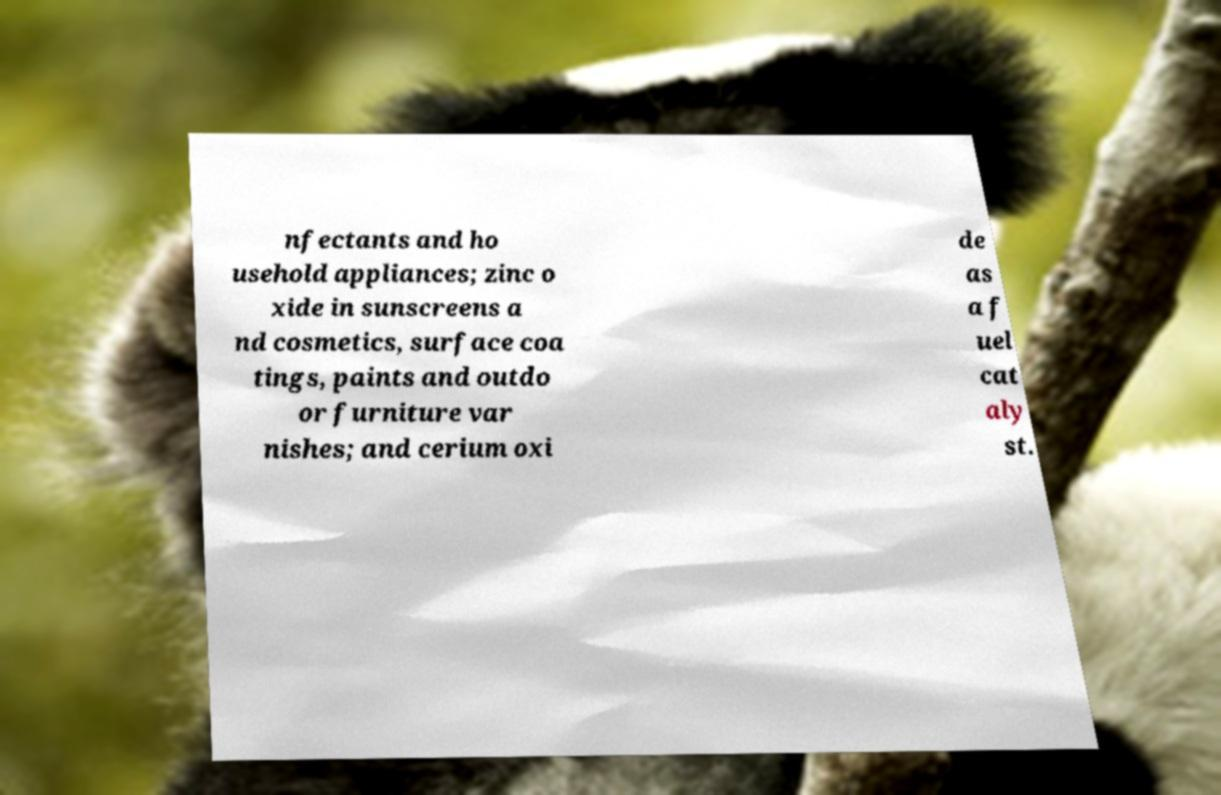What messages or text are displayed in this image? I need them in a readable, typed format. nfectants and ho usehold appliances; zinc o xide in sunscreens a nd cosmetics, surface coa tings, paints and outdo or furniture var nishes; and cerium oxi de as a f uel cat aly st. 